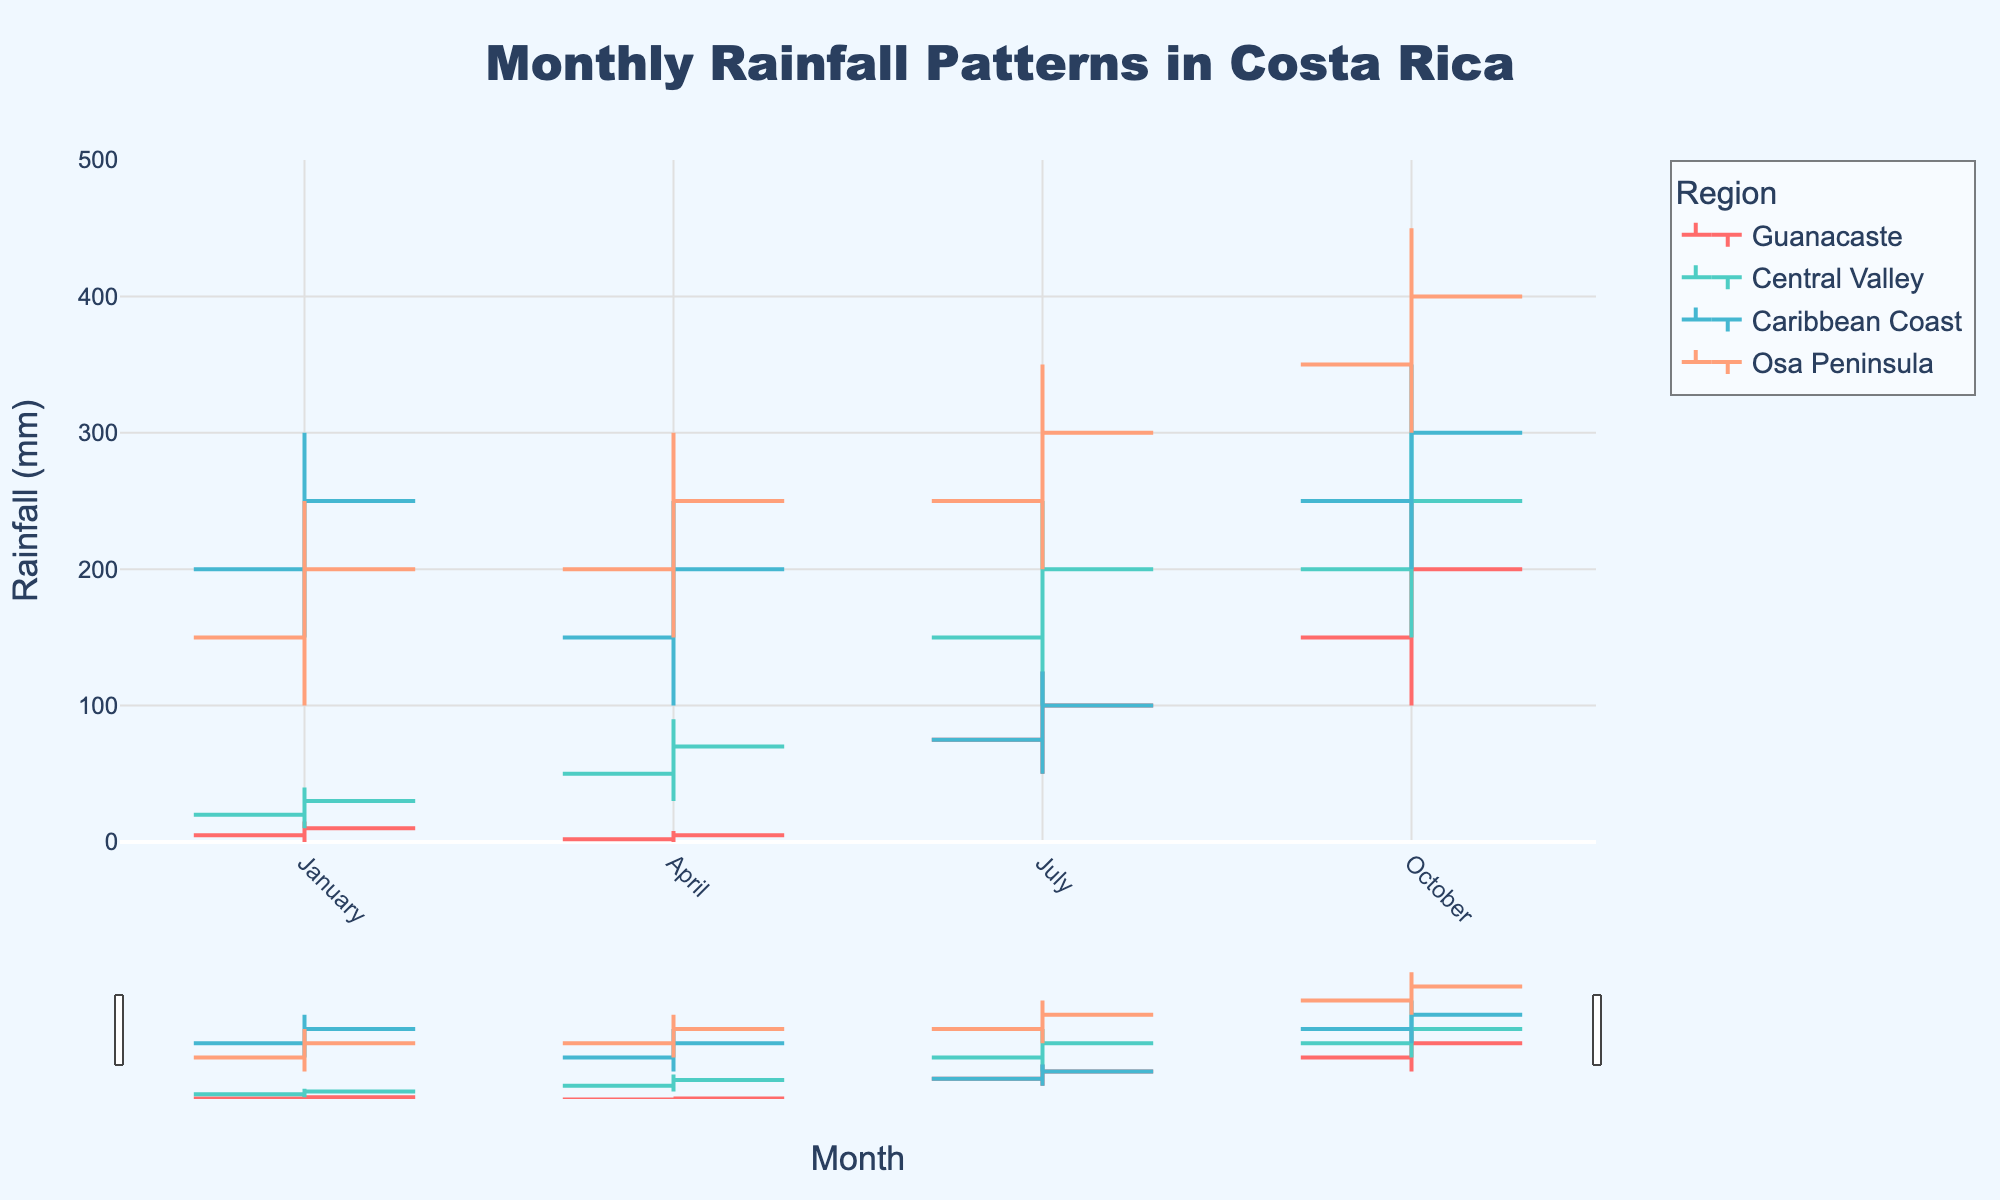What is the title of the chart? The title is usually placed at the top of the chart. In this case, it's "Monthly Rainfall Patterns in Costa Rica".
Answer: Monthly Rainfall Patterns in Costa Rica How many regions are represented in this chart? By looking at the legend or different lines on the chart, we can identify the number of regions. Here, we see Guanacaste, Central Valley, Caribbean Coast, and Osa Peninsula.
Answer: 4 Which region has the highest rainfall in October? By observing the OHLC (high value) for October in all regions, Osa Peninsula has the highest value of 450 mm.
Answer: Osa Peninsula In which month does Guanacaste experience the highest rainfall? The highest value for Guanacaste can be found by checking the high values in each month. July has a high of 125 mm, but October has 250 mm, which is higher.
Answer: October What are the rainfall values for Central Valley in January? For January, the OHLC values for Central Valley are shown on the chart. The values are Low: 10 mm, Open: 20 mm, Close: 30 mm, and High: 40 mm.
Answer: Low: 10, Open: 20, Close: 30, High: 40 Which region has the lowest rainfall in April? Checking the low values for all regions in April, Guanacaste has the lowest value of 0 mm.
Answer: Guanacaste Compare the rainfall patterns of Guanacaste and the Caribbean Coast in July. Observing July's OHLC values for both regions: Guanacaste has values Low: 50 mm, Open: 75 mm, Close: 100 mm, and High: 125 mm. Caribbean Coast has values Low: 50 mm, Open: 75 mm, Close: 100 mm, and High: 125 mm. They have identical patterns in July.
Answer: Identical patterns Calculate the average open rainfall value for the Osa Peninsula over all months. The open values for the Osa Peninsula are 150 mm (Jan), 200 mm (Apr), 250 mm (Jul), 350 mm (Oct). Summing these gives 150 + 200 + 250 + 350 = 950. There are 4 values, so the average is 950/4.
Answer: 237.5 Which month has the highest range of rainfall in the Central Valley? The range is calculated as High - Low. For January: 40-10=30, April: 90-30=60, July: 250-100=150, October: 300-150=150. Both July and October have the highest range of 150 mm.
Answer: July and October Identify the month with the lowest close rainfall value for the Caribbean Coast. By checking the close values for Caribbean Coast: Jan (250 mm), Apr (200 mm), Jul (100 mm), Oct (300 mm), July has the lowest close value of 100 mm.
Answer: July 